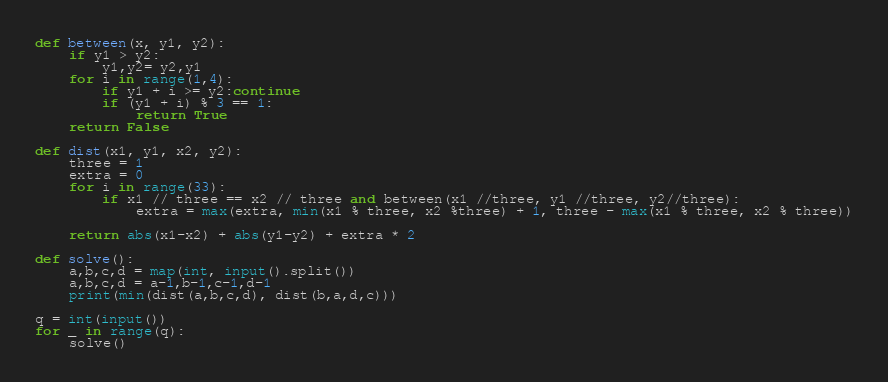<code> <loc_0><loc_0><loc_500><loc_500><_Python_>def between(x, y1, y2):
    if y1 > y2:
        y1,y2= y2,y1
    for i in range(1,4):
        if y1 + i >= y2:continue
        if (y1 + i) % 3 == 1:
            return True
    return False
    
def dist(x1, y1, x2, y2):
    three = 1
    extra = 0
    for i in range(33):
        if x1 // three == x2 // three and between(x1 //three, y1 //three, y2//three):
            extra = max(extra, min(x1 % three, x2 %three) + 1, three - max(x1 % three, x2 % three))

    return abs(x1-x2) + abs(y1-y2) + extra * 2

def solve():
    a,b,c,d = map(int, input().split())
    a,b,c,d = a-1,b-1,c-1,d-1
    print(min(dist(a,b,c,d), dist(b,a,d,c)))

q = int(input())
for _ in range(q):
    solve()</code> 